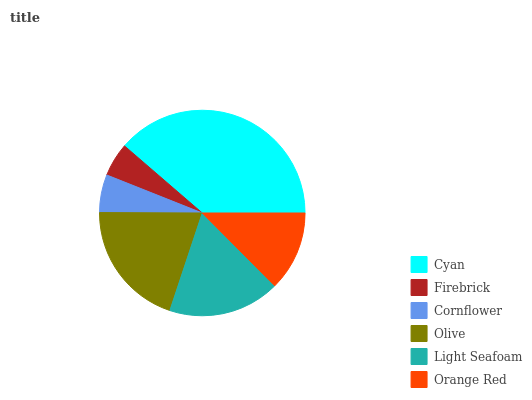Is Firebrick the minimum?
Answer yes or no. Yes. Is Cyan the maximum?
Answer yes or no. Yes. Is Cornflower the minimum?
Answer yes or no. No. Is Cornflower the maximum?
Answer yes or no. No. Is Cornflower greater than Firebrick?
Answer yes or no. Yes. Is Firebrick less than Cornflower?
Answer yes or no. Yes. Is Firebrick greater than Cornflower?
Answer yes or no. No. Is Cornflower less than Firebrick?
Answer yes or no. No. Is Light Seafoam the high median?
Answer yes or no. Yes. Is Orange Red the low median?
Answer yes or no. Yes. Is Orange Red the high median?
Answer yes or no. No. Is Cyan the low median?
Answer yes or no. No. 